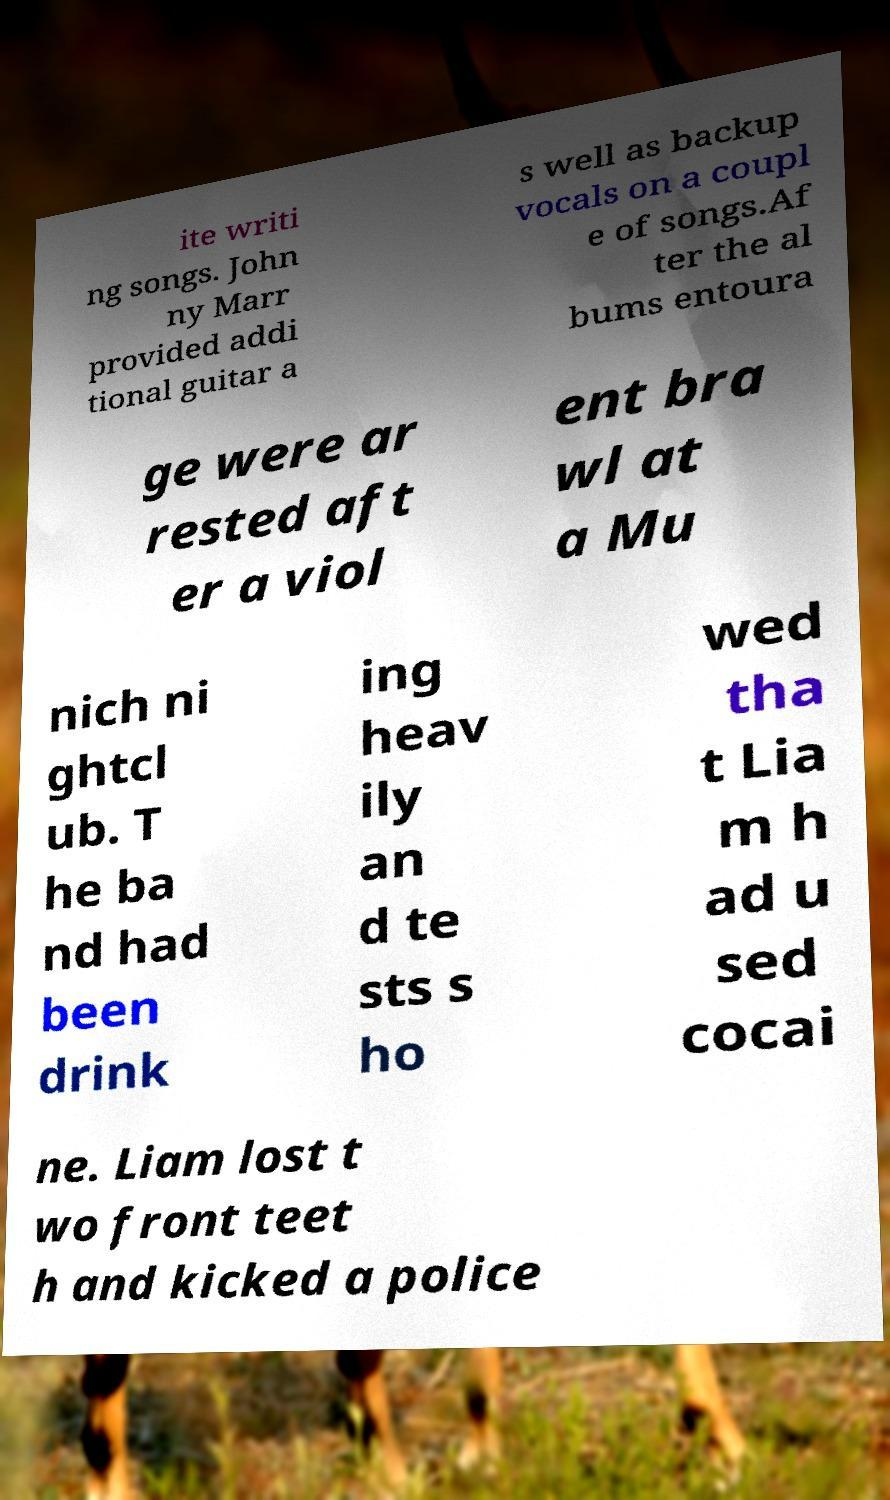For documentation purposes, I need the text within this image transcribed. Could you provide that? ite writi ng songs. John ny Marr provided addi tional guitar a s well as backup vocals on a coupl e of songs.Af ter the al bums entoura ge were ar rested aft er a viol ent bra wl at a Mu nich ni ghtcl ub. T he ba nd had been drink ing heav ily an d te sts s ho wed tha t Lia m h ad u sed cocai ne. Liam lost t wo front teet h and kicked a police 